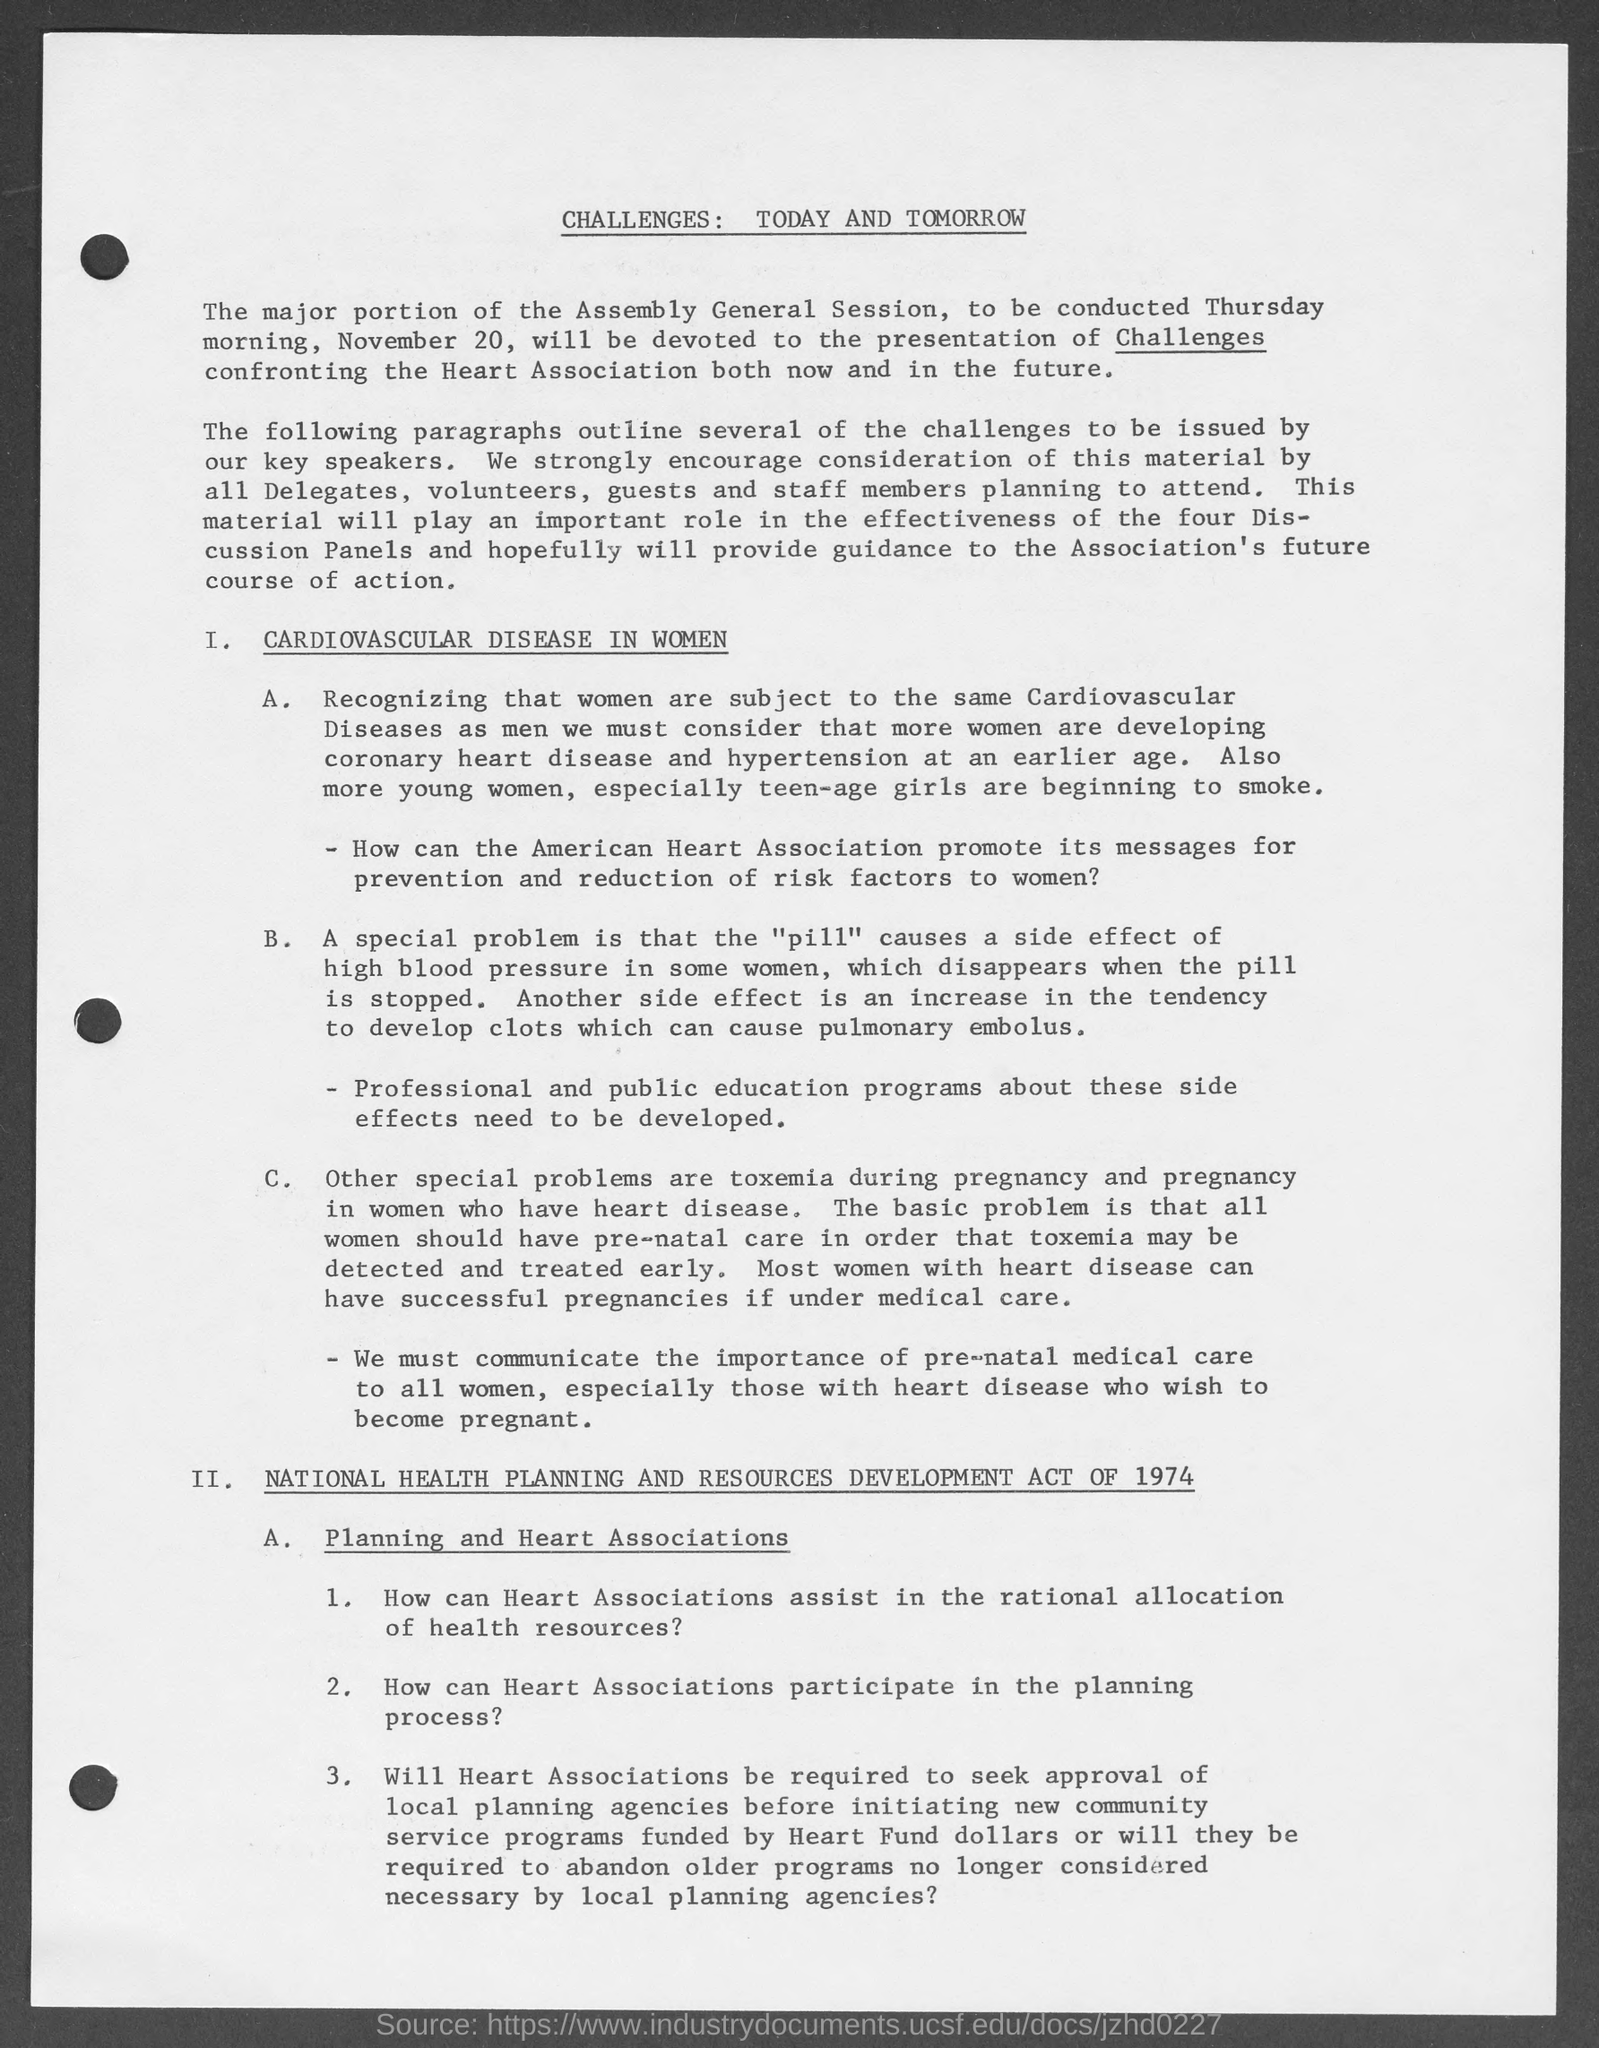What strategies are proposed here to address cardiovascular issues in women? The image outlines the need for the American Heart Association to promote messages for prevention and reduction of risk factors in women. It includes developing cardiovascular diseases at an earlier age and recognizing the special problems from 'pill' side effects. Education programs and consideration of pre-natal care for women with heart disease are also proposed as strategies. 